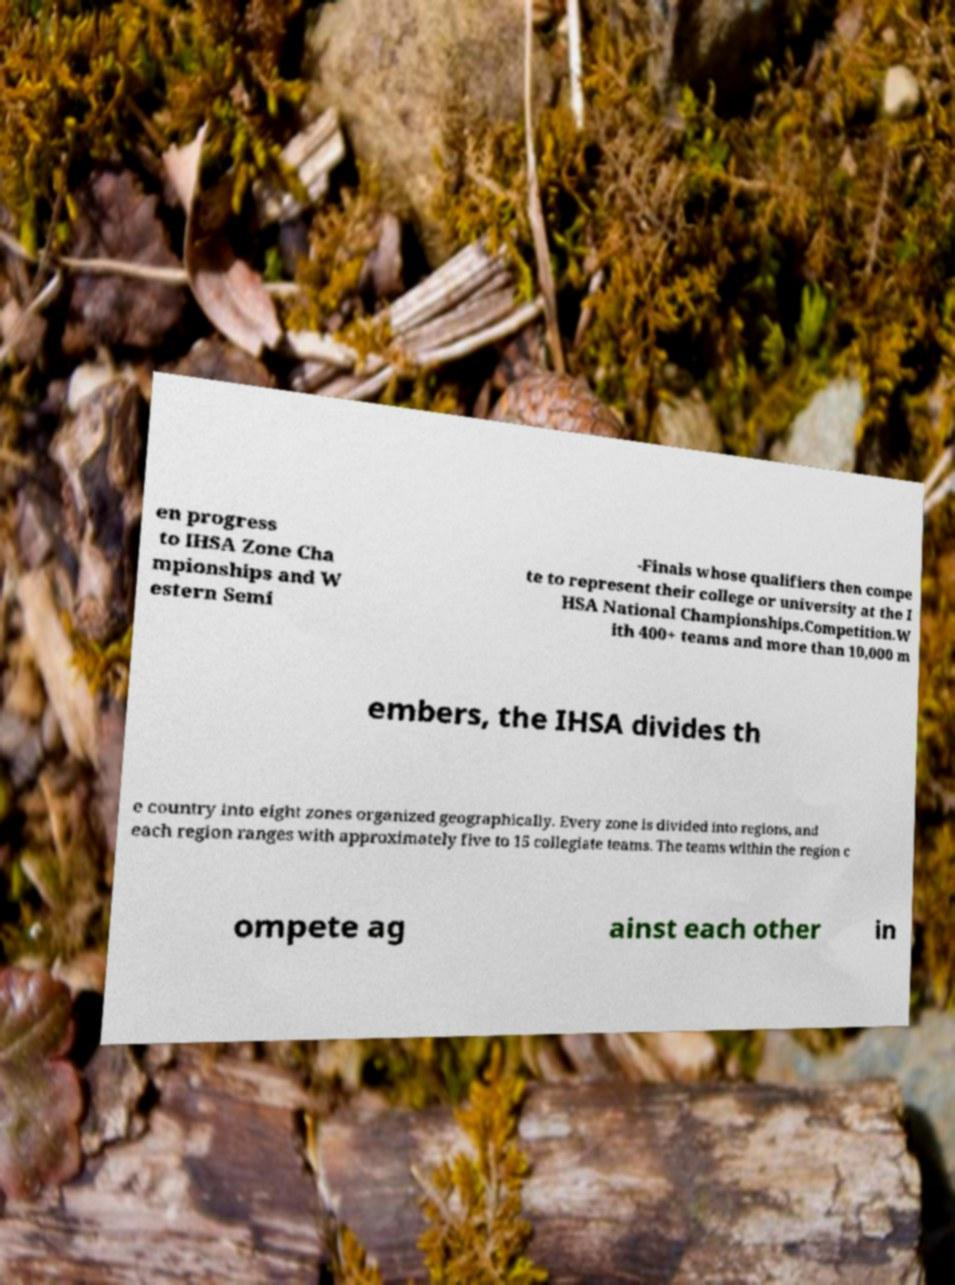Can you read and provide the text displayed in the image?This photo seems to have some interesting text. Can you extract and type it out for me? en progress to IHSA Zone Cha mpionships and W estern Semi -Finals whose qualifiers then compe te to represent their college or university at the I HSA National Championships.Competition.W ith 400+ teams and more than 10,000 m embers, the IHSA divides th e country into eight zones organized geographically. Every zone is divided into regions, and each region ranges with approximately five to 15 collegiate teams. The teams within the region c ompete ag ainst each other in 